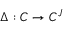<formula> <loc_0><loc_0><loc_500><loc_500>\Delta \colon C \to C ^ { J }</formula> 